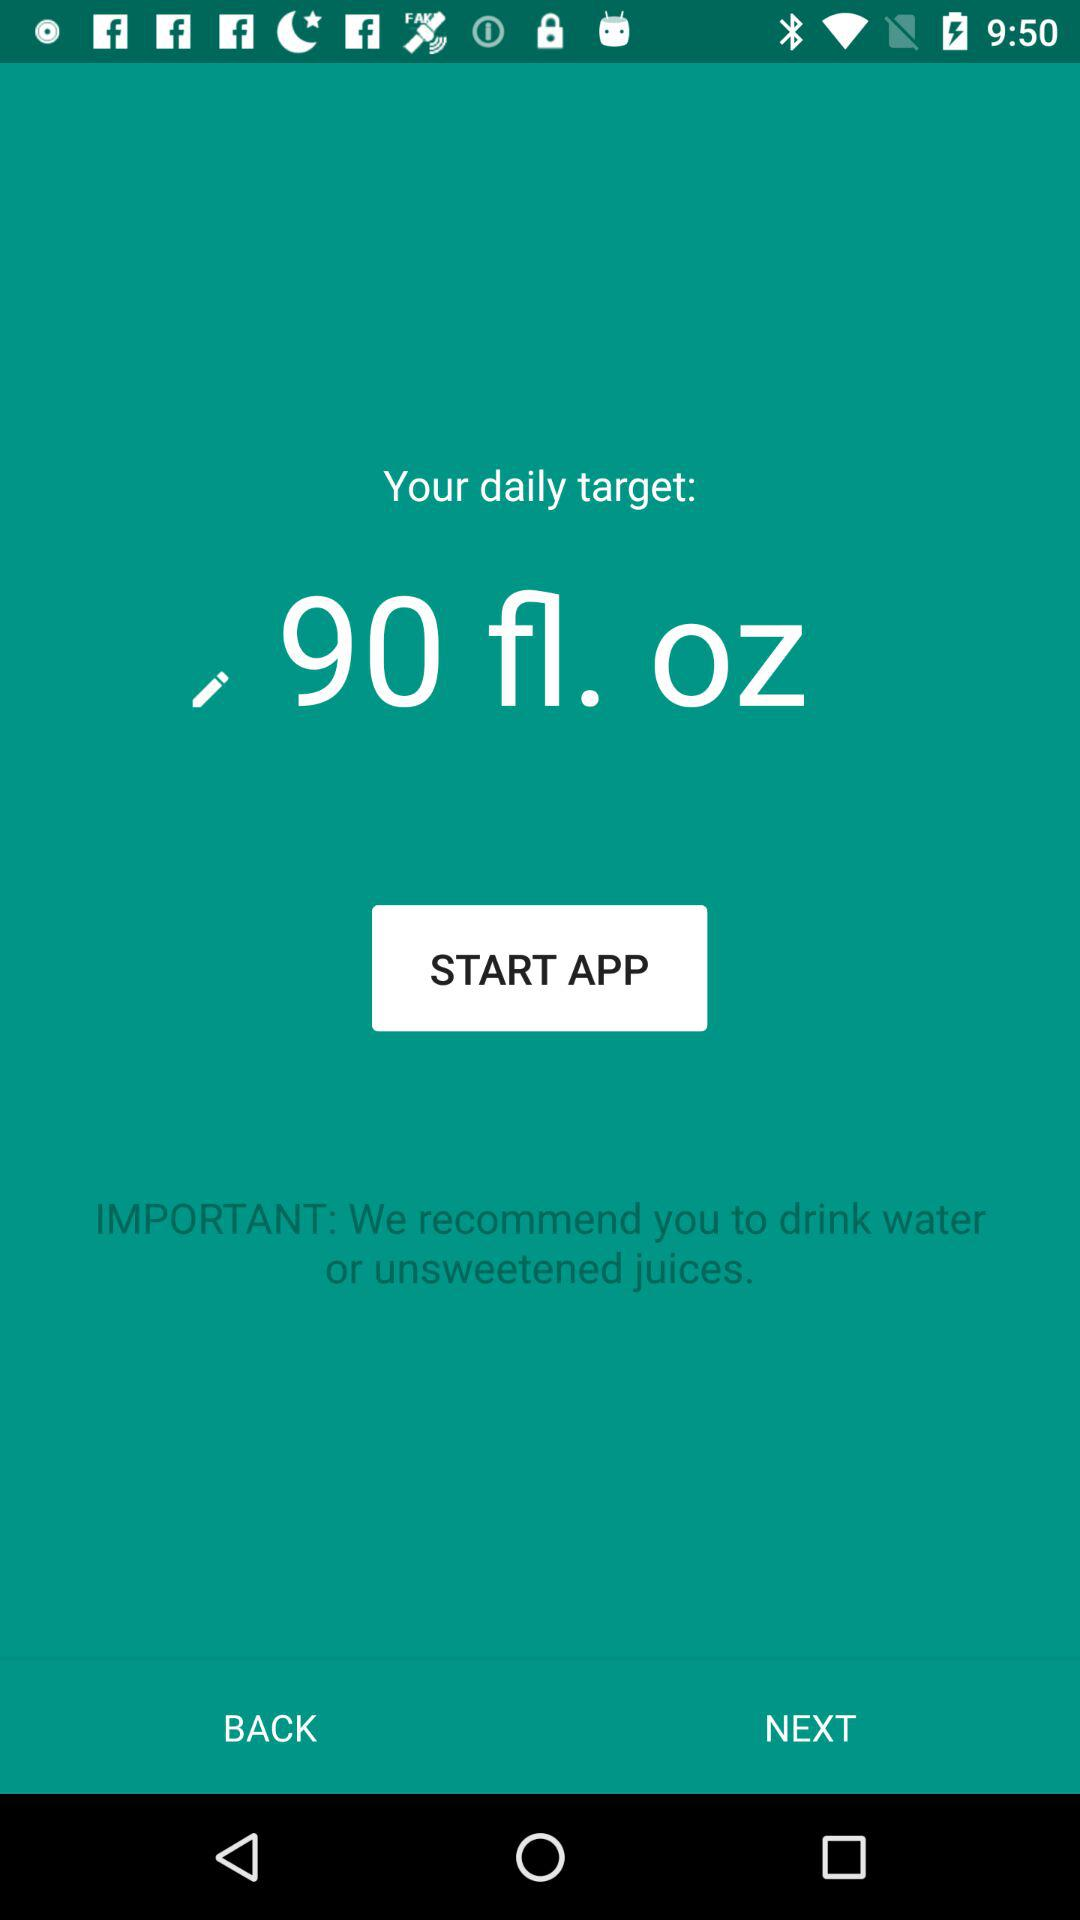How many ounces of water do I need to drink to meet my daily target?
Answer the question using a single word or phrase. 90 